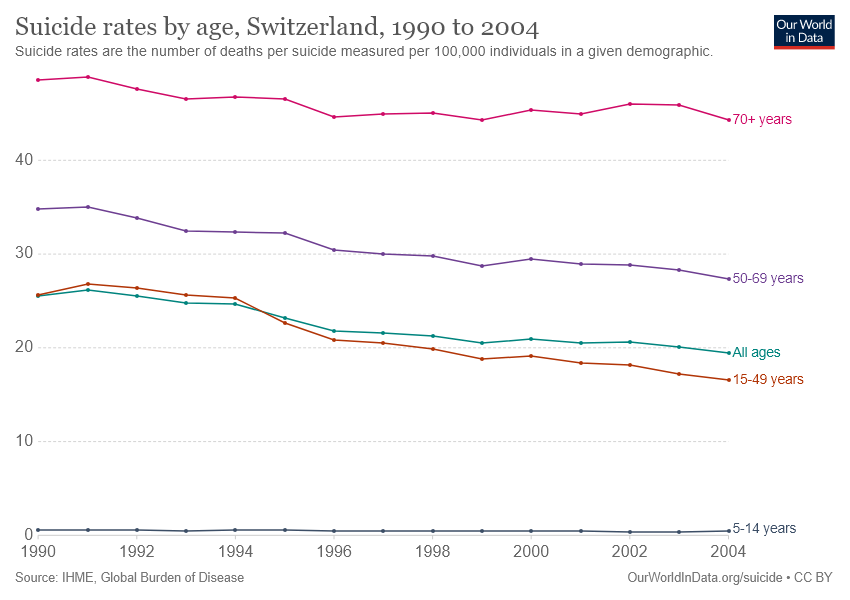Point out several critical features in this image. In the year 1990, the highest suicide rate was recorded among people aged 50-69 years. In 2004, Switzerland recorded the lowest suicide rate among individuals aged 70 and older. 